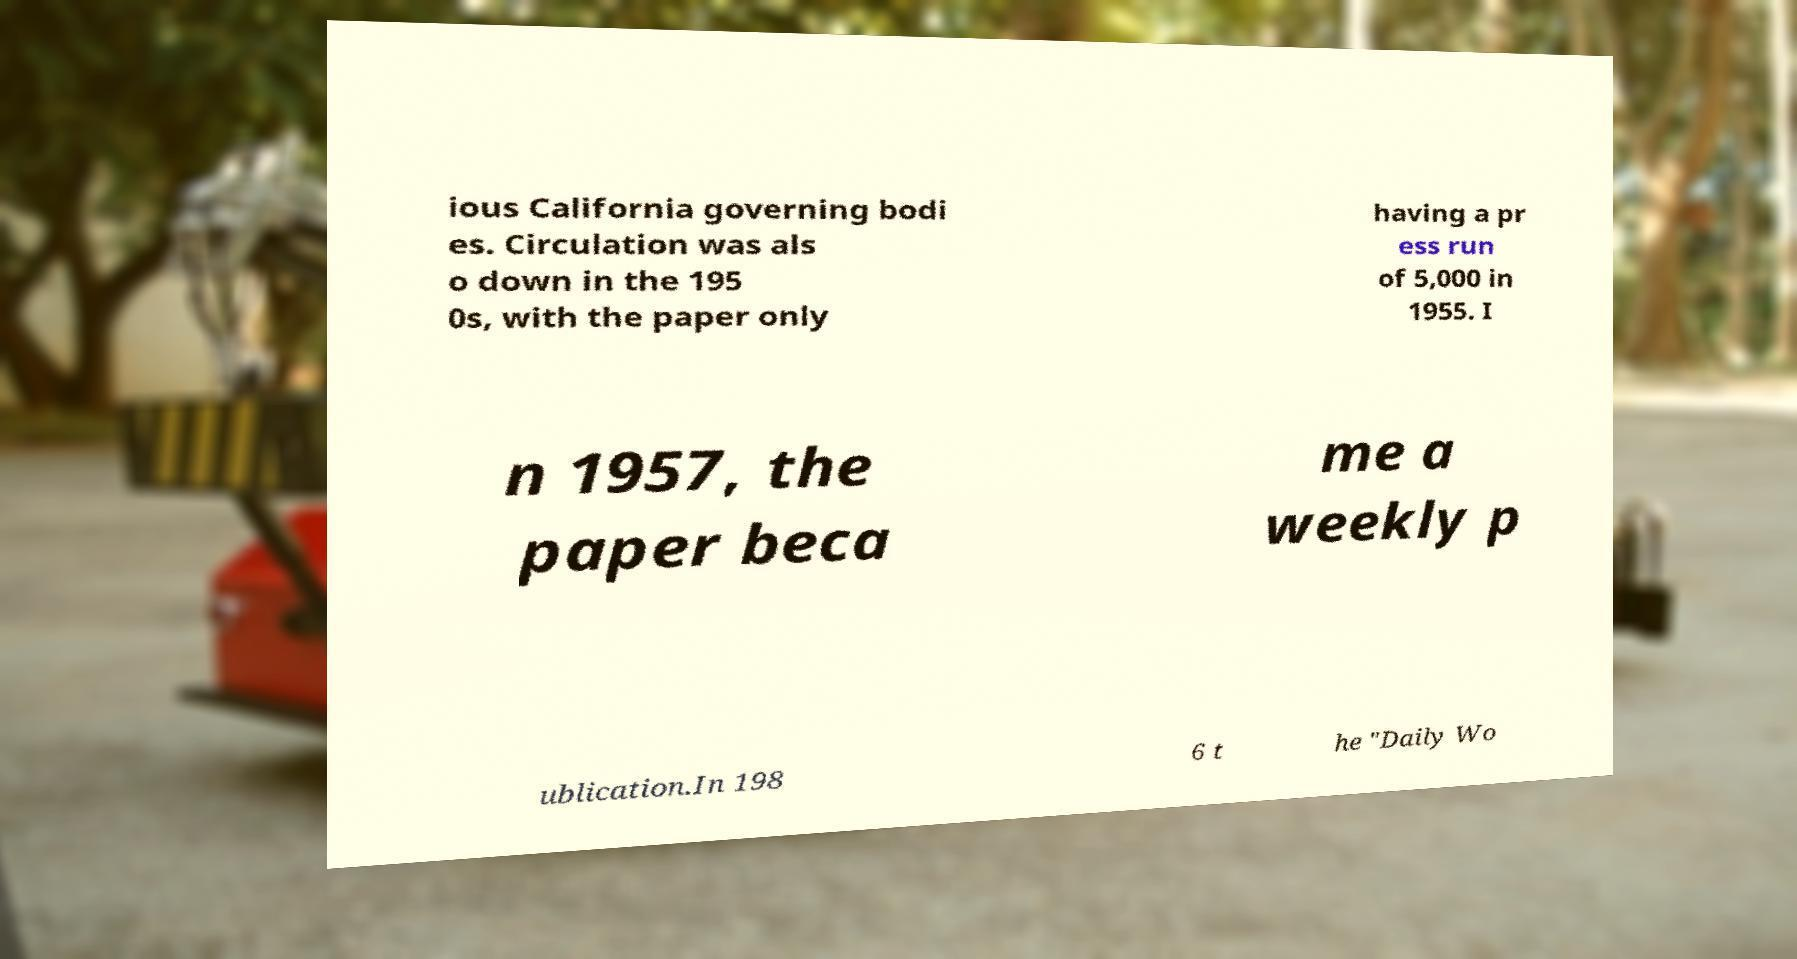Can you accurately transcribe the text from the provided image for me? ious California governing bodi es. Circulation was als o down in the 195 0s, with the paper only having a pr ess run of 5,000 in 1955. I n 1957, the paper beca me a weekly p ublication.In 198 6 t he "Daily Wo 